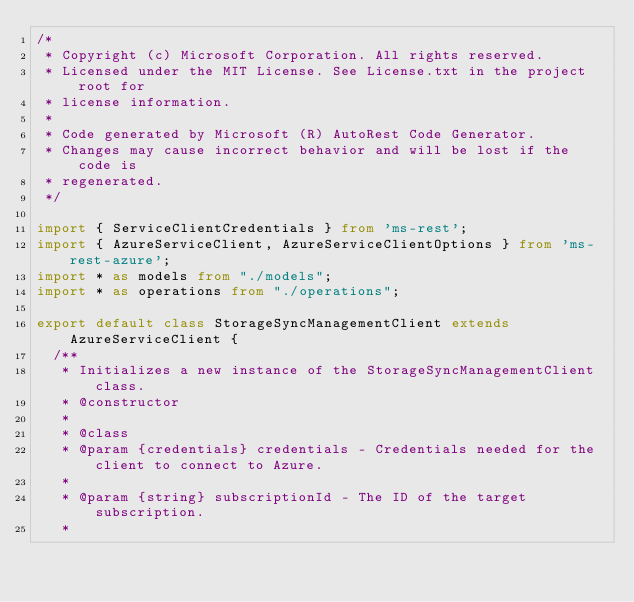<code> <loc_0><loc_0><loc_500><loc_500><_TypeScript_>/*
 * Copyright (c) Microsoft Corporation. All rights reserved.
 * Licensed under the MIT License. See License.txt in the project root for
 * license information.
 *
 * Code generated by Microsoft (R) AutoRest Code Generator.
 * Changes may cause incorrect behavior and will be lost if the code is
 * regenerated.
 */

import { ServiceClientCredentials } from 'ms-rest';
import { AzureServiceClient, AzureServiceClientOptions } from 'ms-rest-azure';
import * as models from "./models";
import * as operations from "./operations";

export default class StorageSyncManagementClient extends AzureServiceClient {
  /**
   * Initializes a new instance of the StorageSyncManagementClient class.
   * @constructor
   *
   * @class
   * @param {credentials} credentials - Credentials needed for the client to connect to Azure.
   *
   * @param {string} subscriptionId - The ID of the target subscription.
   *</code> 